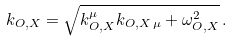<formula> <loc_0><loc_0><loc_500><loc_500>k _ { O , X } = \sqrt { k _ { O , X } ^ { \mu } k _ { O , X \, \mu } + \omega _ { O , X } ^ { 2 } } \, .</formula> 